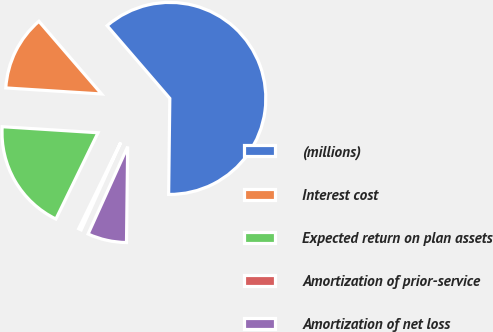Convert chart to OTSL. <chart><loc_0><loc_0><loc_500><loc_500><pie_chart><fcel>(millions)<fcel>Interest cost<fcel>Expected return on plan assets<fcel>Amortization of prior-service<fcel>Amortization of net loss<nl><fcel>61.52%<fcel>12.67%<fcel>18.78%<fcel>0.46%<fcel>6.57%<nl></chart> 